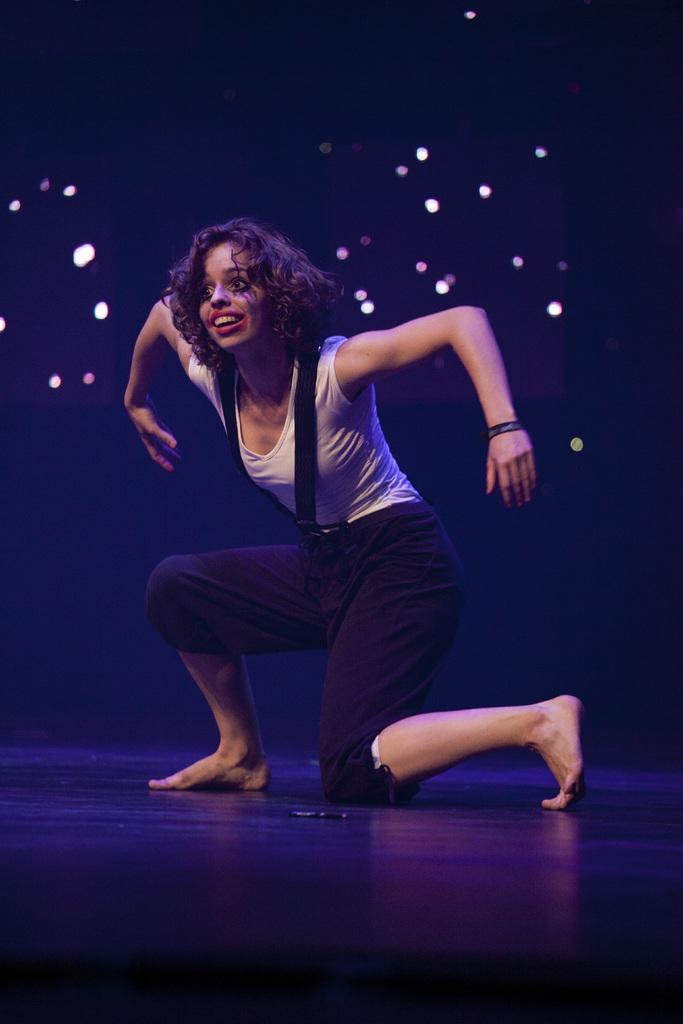Please provide a concise description of this image. There is a lady performing on the stage. In the back there are lights. 